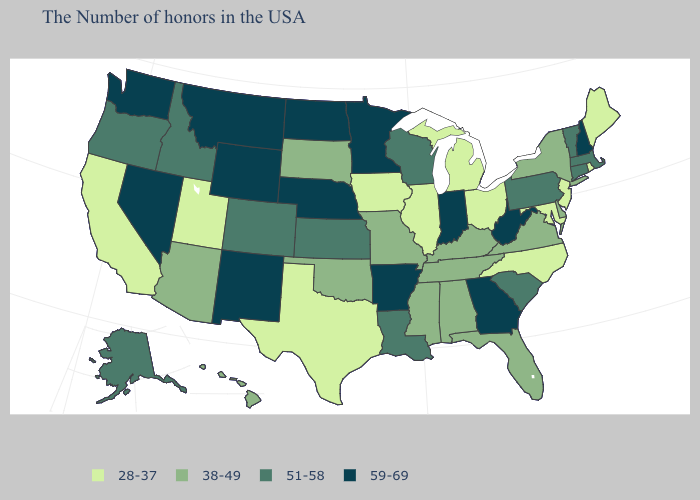Does Nevada have the highest value in the West?
Concise answer only. Yes. Name the states that have a value in the range 59-69?
Write a very short answer. New Hampshire, West Virginia, Georgia, Indiana, Arkansas, Minnesota, Nebraska, North Dakota, Wyoming, New Mexico, Montana, Nevada, Washington. What is the value of Mississippi?
Concise answer only. 38-49. What is the value of Maryland?
Answer briefly. 28-37. Among the states that border Kansas , which have the highest value?
Answer briefly. Nebraska. What is the value of Mississippi?
Write a very short answer. 38-49. Among the states that border California , which have the highest value?
Quick response, please. Nevada. What is the value of Connecticut?
Concise answer only. 51-58. Name the states that have a value in the range 38-49?
Short answer required. New York, Delaware, Virginia, Florida, Kentucky, Alabama, Tennessee, Mississippi, Missouri, Oklahoma, South Dakota, Arizona, Hawaii. Does California have the same value as North Dakota?
Answer briefly. No. What is the value of Louisiana?
Short answer required. 51-58. What is the value of Pennsylvania?
Answer briefly. 51-58. What is the value of Wisconsin?
Be succinct. 51-58. 